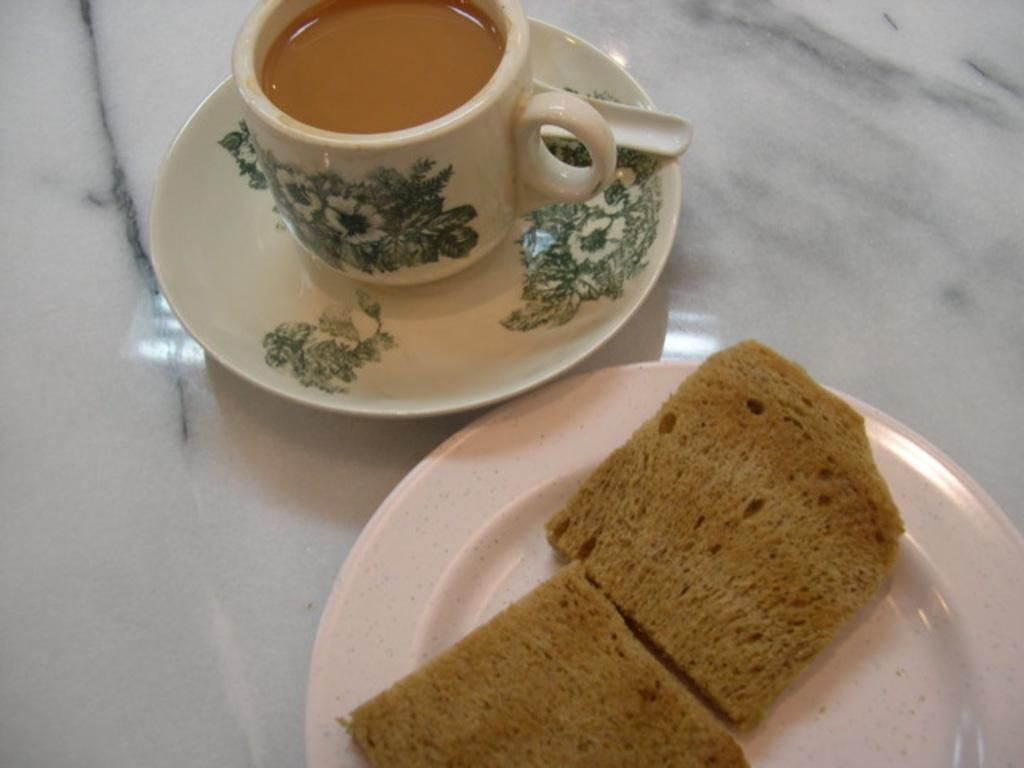What is in the cup that is visible in the image? There is a tea cup in the image. What is the tea cup placed on? There is a saucer in the image. What is inside the tea cup? There is tea in the tea cup. What is on the plate in the image? There is a white color plate in the image. What is on top of the plate? There are two toasts on the plate. What type of brush is used to spread the jam on the toasts in the image? There is no brush or jam present in the image; it only shows a tea cup, saucer, tea, plate, and toasts. 